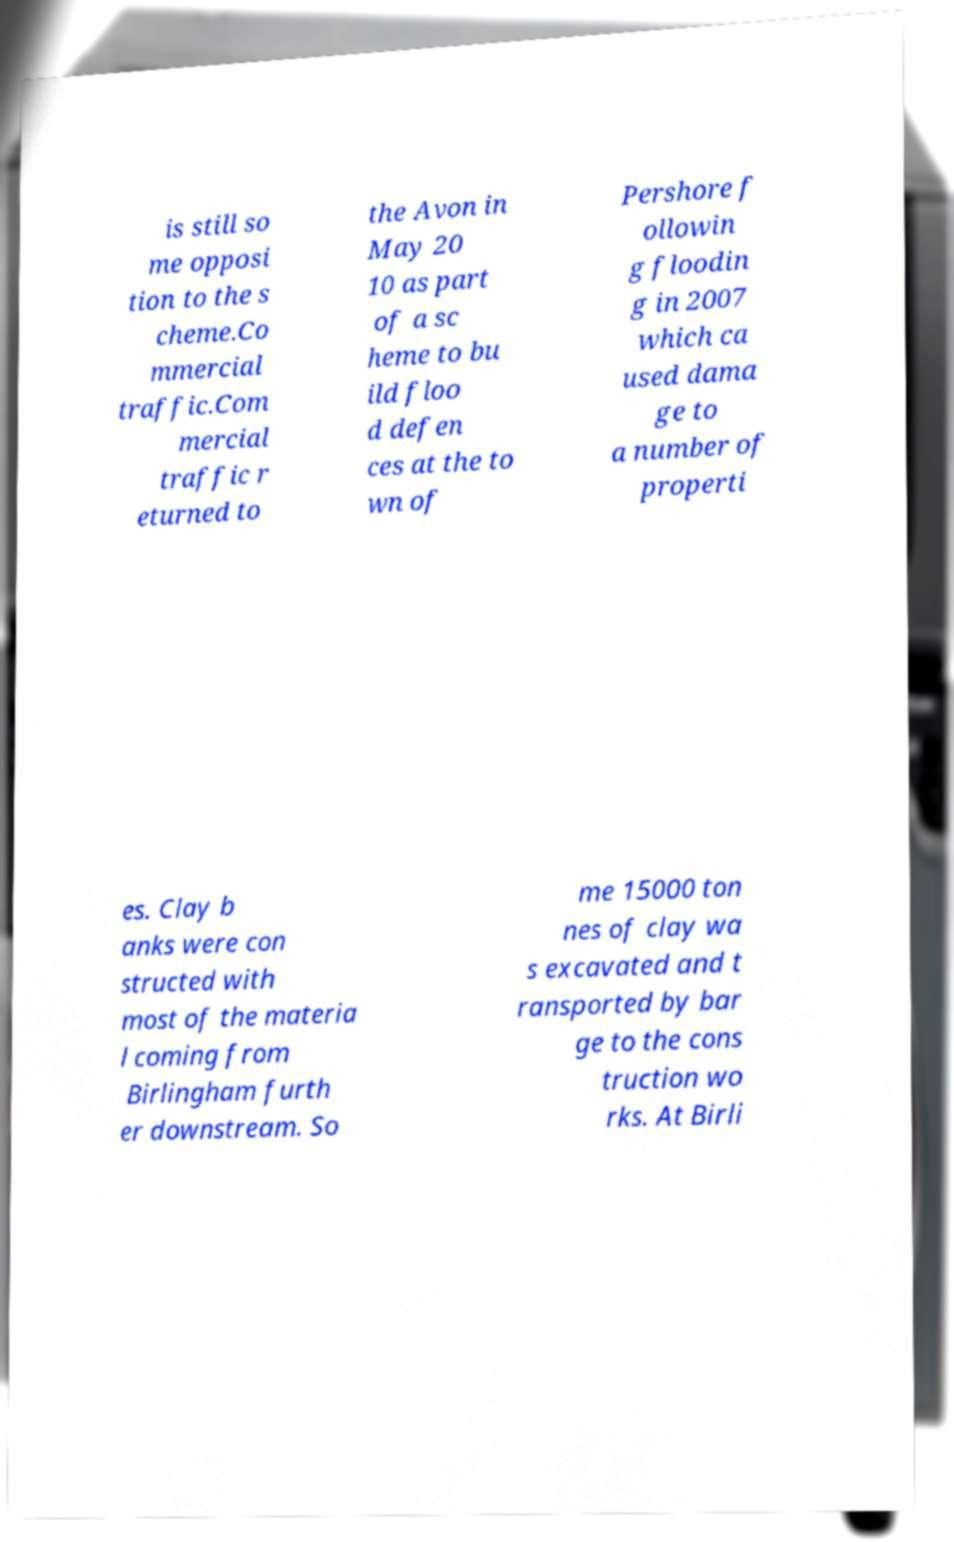Can you read and provide the text displayed in the image?This photo seems to have some interesting text. Can you extract and type it out for me? is still so me opposi tion to the s cheme.Co mmercial traffic.Com mercial traffic r eturned to the Avon in May 20 10 as part of a sc heme to bu ild floo d defen ces at the to wn of Pershore f ollowin g floodin g in 2007 which ca used dama ge to a number of properti es. Clay b anks were con structed with most of the materia l coming from Birlingham furth er downstream. So me 15000 ton nes of clay wa s excavated and t ransported by bar ge to the cons truction wo rks. At Birli 